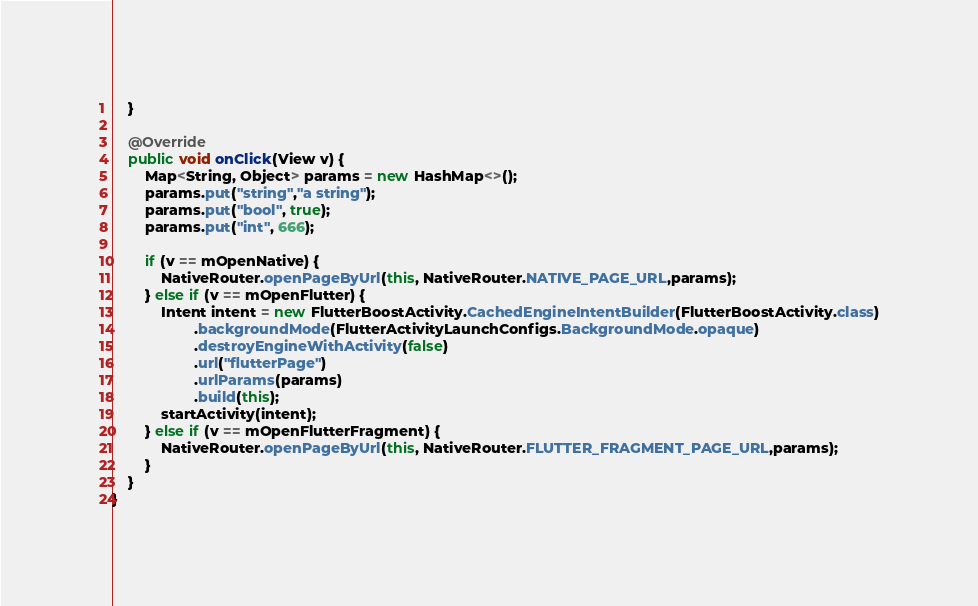<code> <loc_0><loc_0><loc_500><loc_500><_Java_>    }

    @Override
    public void onClick(View v) {
        Map<String, Object> params = new HashMap<>();
        params.put("string","a string");
        params.put("bool", true);
        params.put("int", 666);

        if (v == mOpenNative) {
            NativeRouter.openPageByUrl(this, NativeRouter.NATIVE_PAGE_URL,params);
        } else if (v == mOpenFlutter) {
            Intent intent = new FlutterBoostActivity.CachedEngineIntentBuilder(FlutterBoostActivity.class)
                    .backgroundMode(FlutterActivityLaunchConfigs.BackgroundMode.opaque)
                    .destroyEngineWithActivity(false)
                    .url("flutterPage")
                    .urlParams(params)
                    .build(this);
            startActivity(intent);
        } else if (v == mOpenFlutterFragment) {
            NativeRouter.openPageByUrl(this, NativeRouter.FLUTTER_FRAGMENT_PAGE_URL,params);
        }
    }
}
</code> 